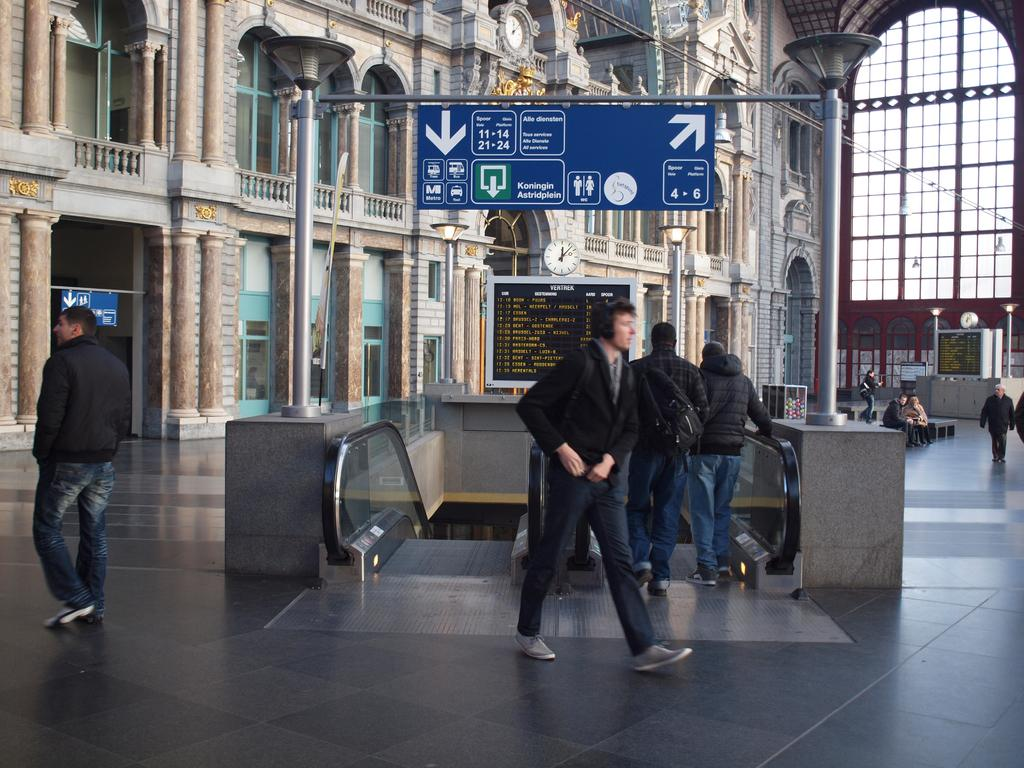How many people are in the group visible in the image? There is a group of people standing in the image, but the exact number cannot be determined from the provided facts. What objects can be seen in the image besides the people? There are boards, lights, poles, clocks, and escalators visible in the image. What type of structure is present in the image? There is a building in the image. What type of coach can be seen driving through the building in the image? There is no coach or any indication of a vehicle driving through the building in the image. How many fowl are perched on the poles in the image? There are no fowl present in the image; only people, boards, lights, poles, clocks, escalators, and a building are visible. 